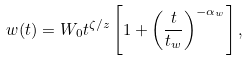<formula> <loc_0><loc_0><loc_500><loc_500>w ( t ) = W _ { 0 } t ^ { \zeta / z } \left [ 1 + \left ( \frac { t } { t _ { w } } \right ) ^ { - \alpha _ { w } } \right ] ,</formula> 